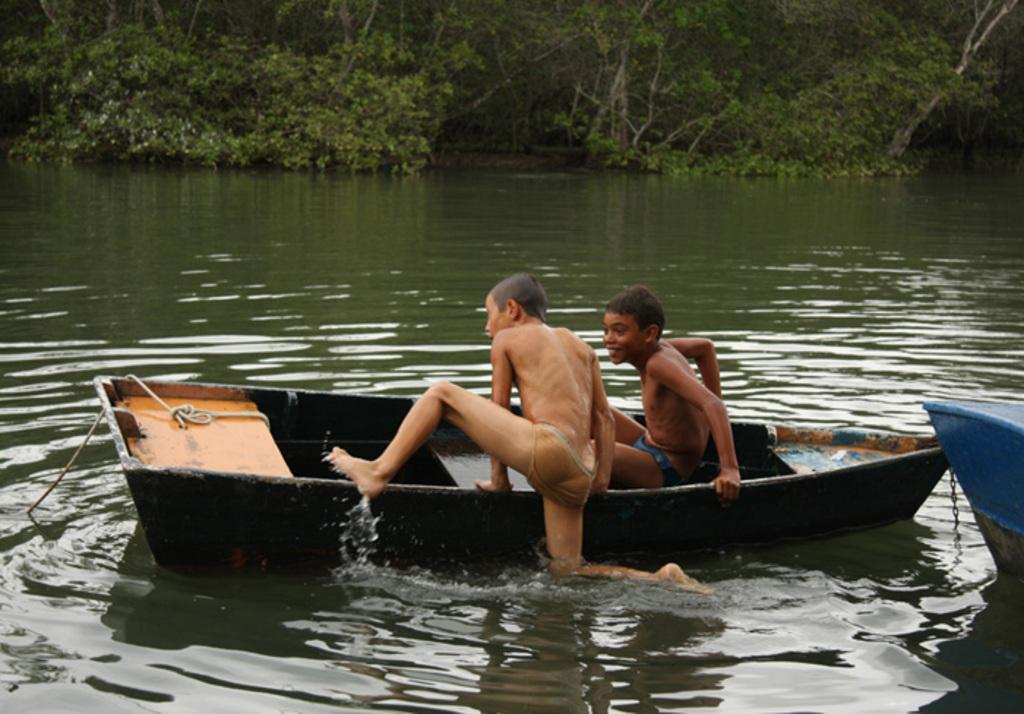How many boats are in the image? There are two boats in the image. Where are the boats located? The boats are on a river. What is happening in the first boat? In one boat, there is a boy sitting. What is happening in the second boat? Another boy is jumping into the boat. What can be seen in the background of the image? There are trees in the background of the image. What type of pipe is being used by the boy in the first boat? There is no pipe present in the image; the boy is simply sitting in the boat. 